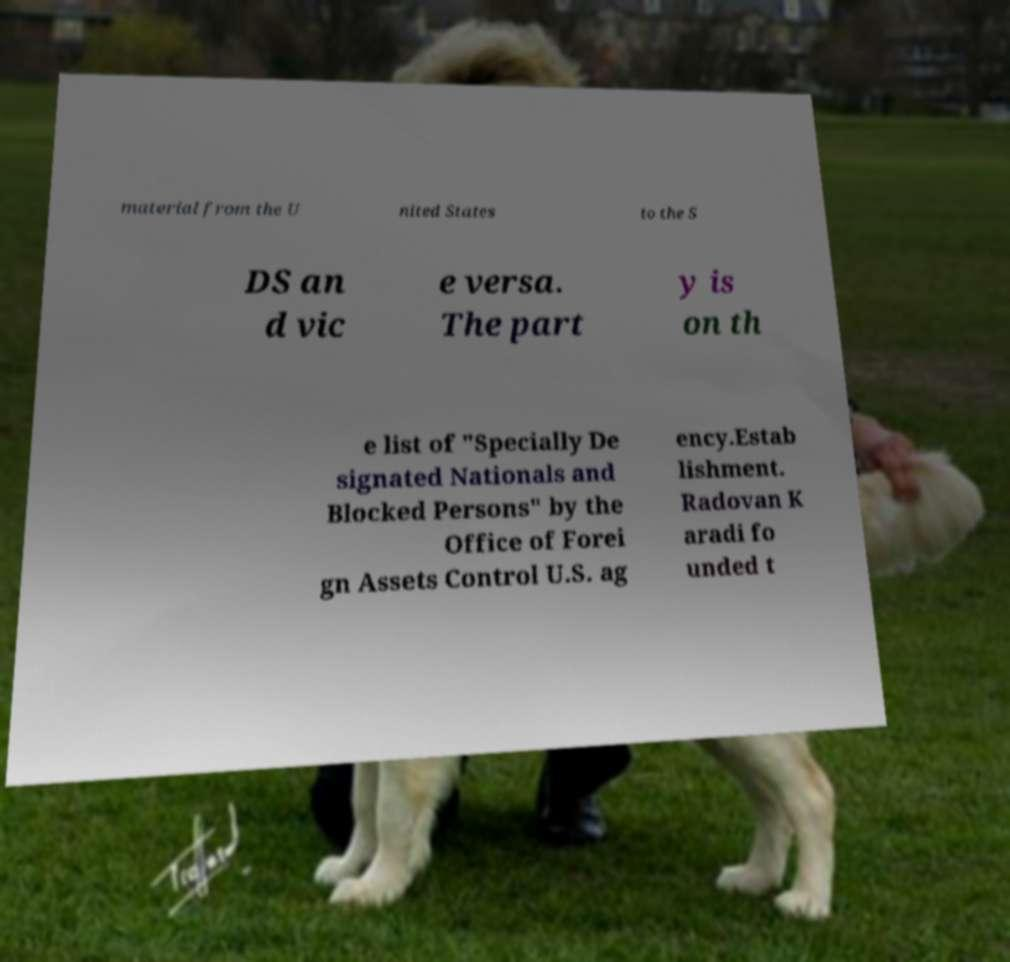Can you accurately transcribe the text from the provided image for me? material from the U nited States to the S DS an d vic e versa. The part y is on th e list of "Specially De signated Nationals and Blocked Persons" by the Office of Forei gn Assets Control U.S. ag ency.Estab lishment. Radovan K aradi fo unded t 